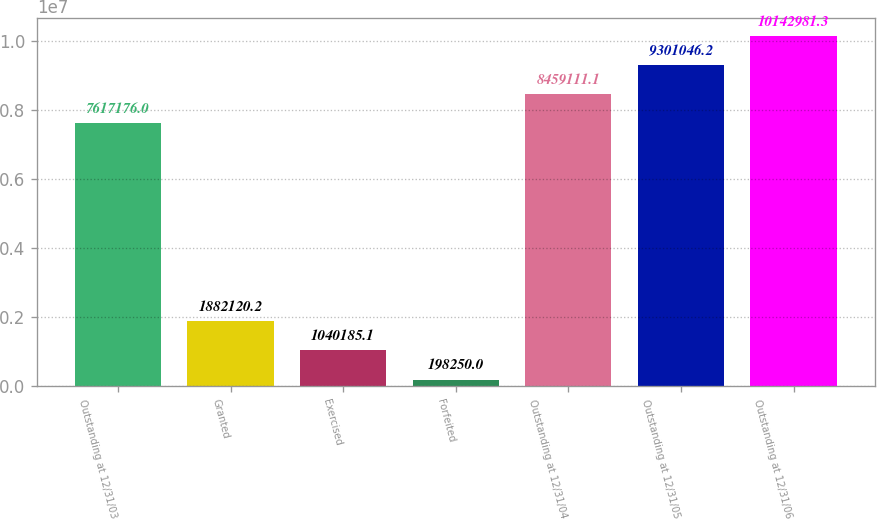<chart> <loc_0><loc_0><loc_500><loc_500><bar_chart><fcel>Outstanding at 12/31/03<fcel>Granted<fcel>Exercised<fcel>Forfeited<fcel>Outstanding at 12/31/04<fcel>Outstanding at 12/31/05<fcel>Outstanding at 12/31/06<nl><fcel>7.61718e+06<fcel>1.88212e+06<fcel>1.04019e+06<fcel>198250<fcel>8.45911e+06<fcel>9.30105e+06<fcel>1.0143e+07<nl></chart> 